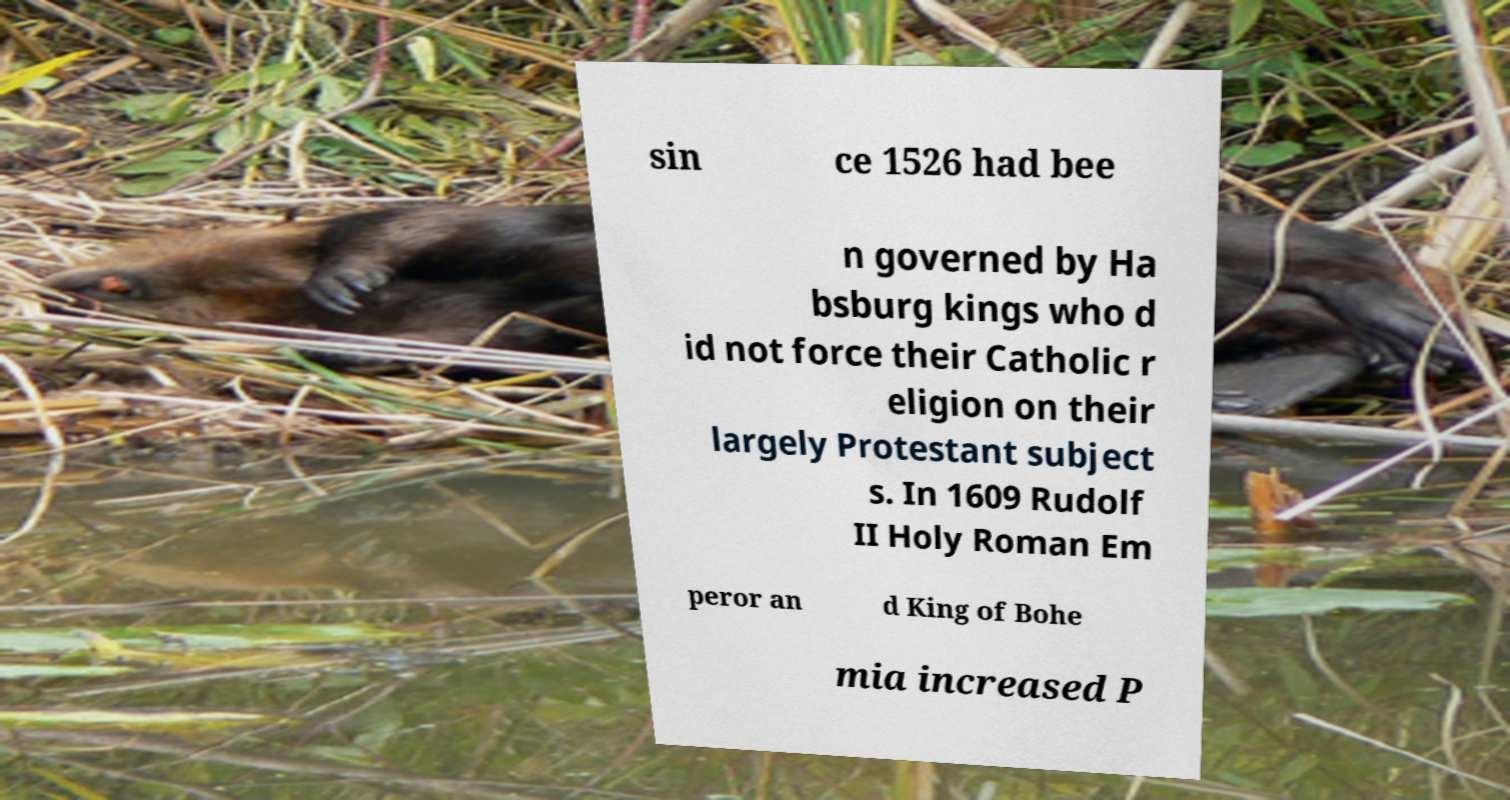Could you assist in decoding the text presented in this image and type it out clearly? sin ce 1526 had bee n governed by Ha bsburg kings who d id not force their Catholic r eligion on their largely Protestant subject s. In 1609 Rudolf II Holy Roman Em peror an d King of Bohe mia increased P 